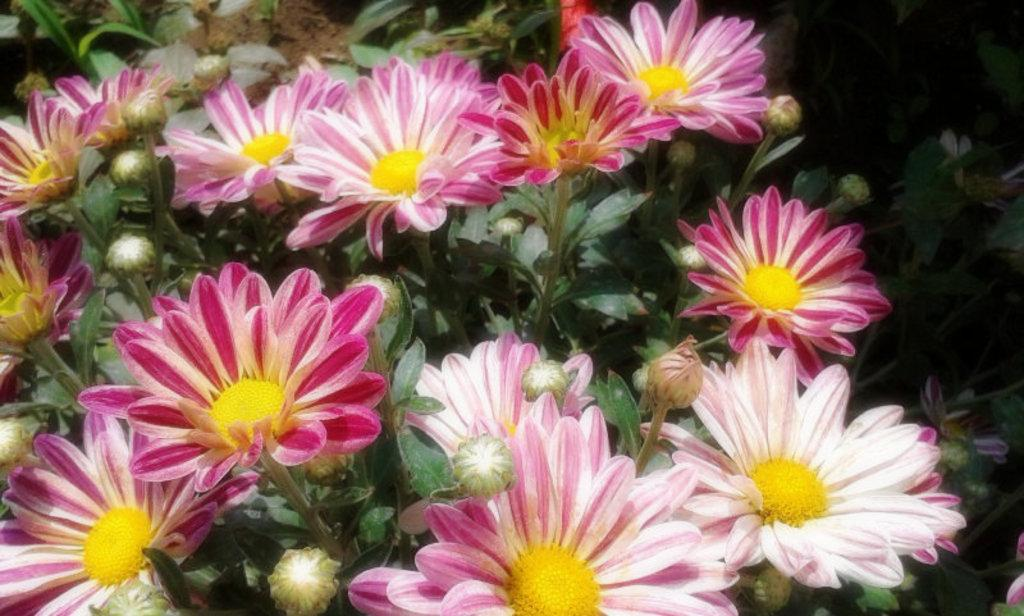What type of plant life is present in the image? There are flowers, buds, and leaves in the image. Can you describe the different stages of growth depicted in the image? The image shows flowers, which are fully bloomed, and buds, which are in the process of blooming. What part of the plant is represented by the leaves in the image? The leaves in the image represent the foliage of the plant. What holiday is being celebrated in the image? There is no indication of a holiday being celebrated in the image; it simply features flowers, buds, and leaves. What activity are the flowers participating in during the image? The flowers are not participating in any activity; they are simply depicted as they are in the image. 